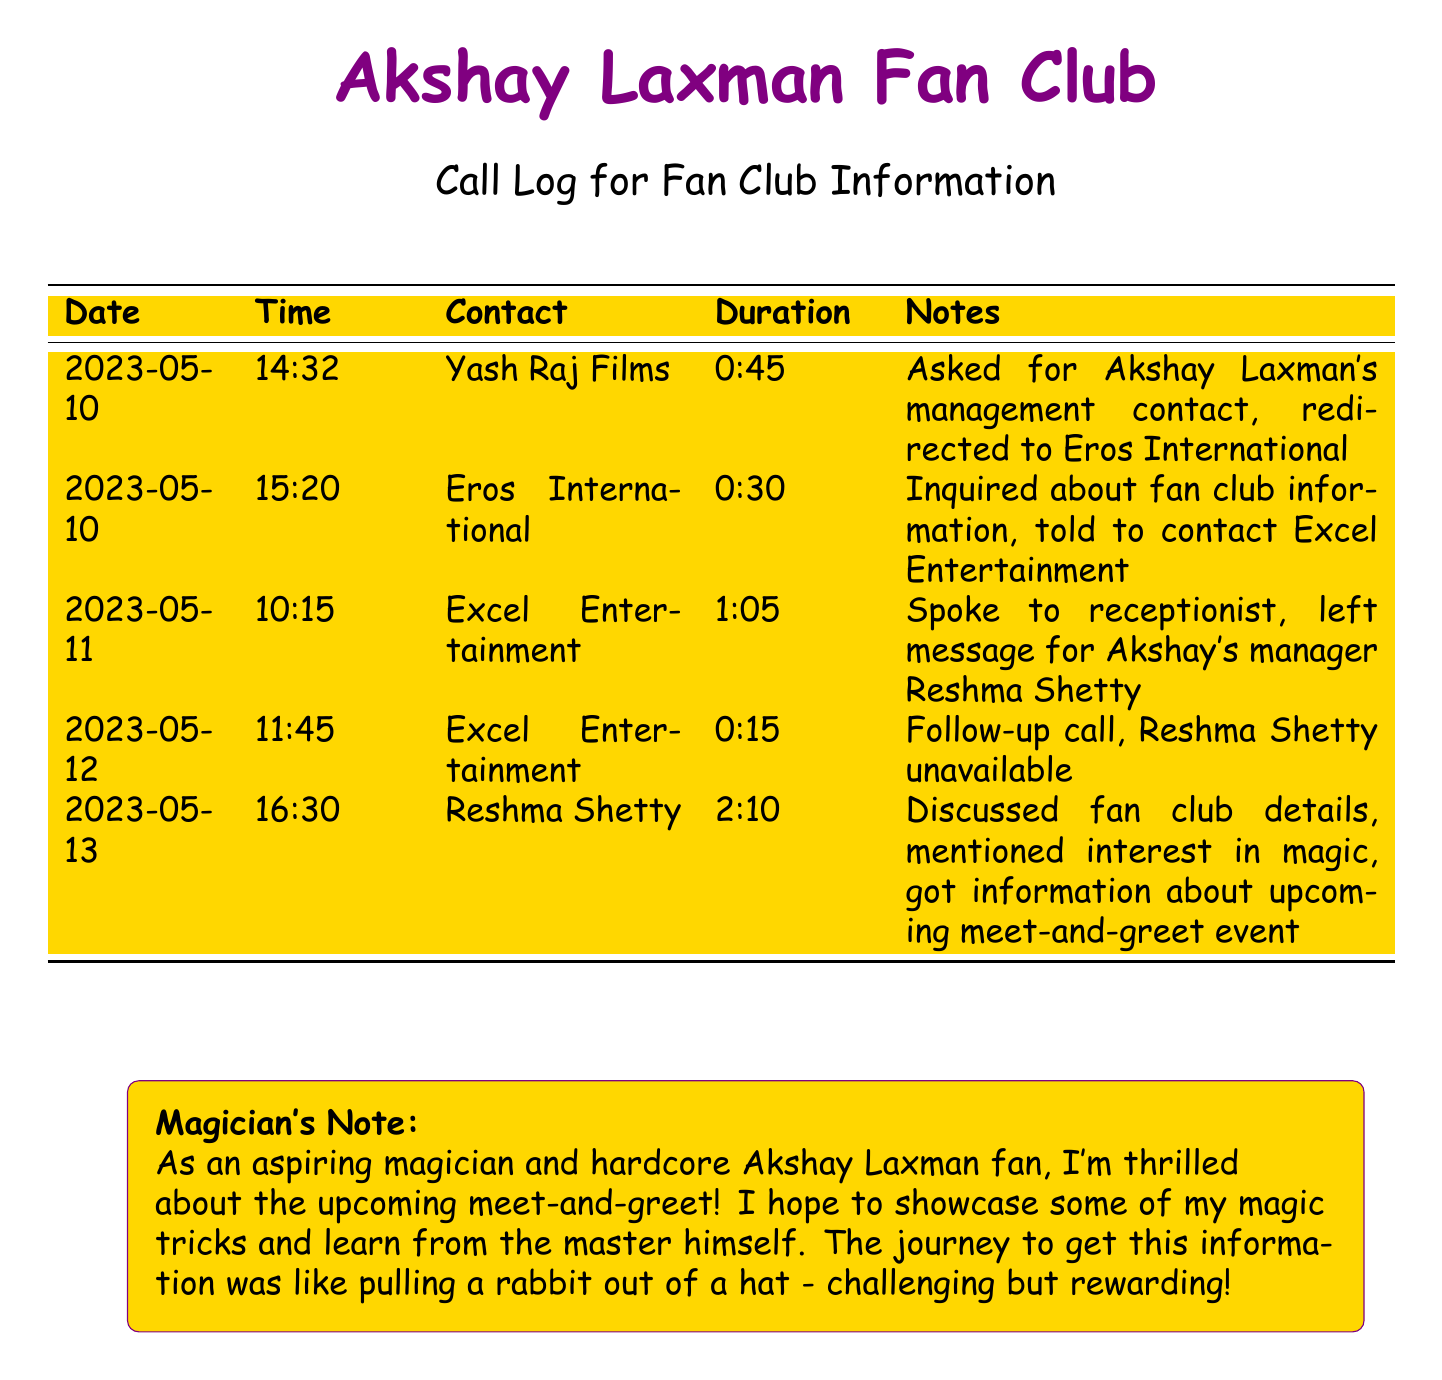What is the date of the first call? The first call is recorded on 2023-05-10 in the document.
Answer: 2023-05-10 Who did the first call contact? The first call was made to Yash Raj Films.
Answer: Yash Raj Films How long did the call to Reshma Shetty last? The call to Reshma Shetty is noted to have a duration of 2 hours and 10 minutes.
Answer: 2:10 What feedback was given by Eros International on the first call? Eros International directed the caller to Excel Entertainment for further inquiries.
Answer: Contact Excel Entertainment What specific detail was discussed during the last call? The last call included details about a meet-and-greet event.
Answer: Meet-and-greet event 